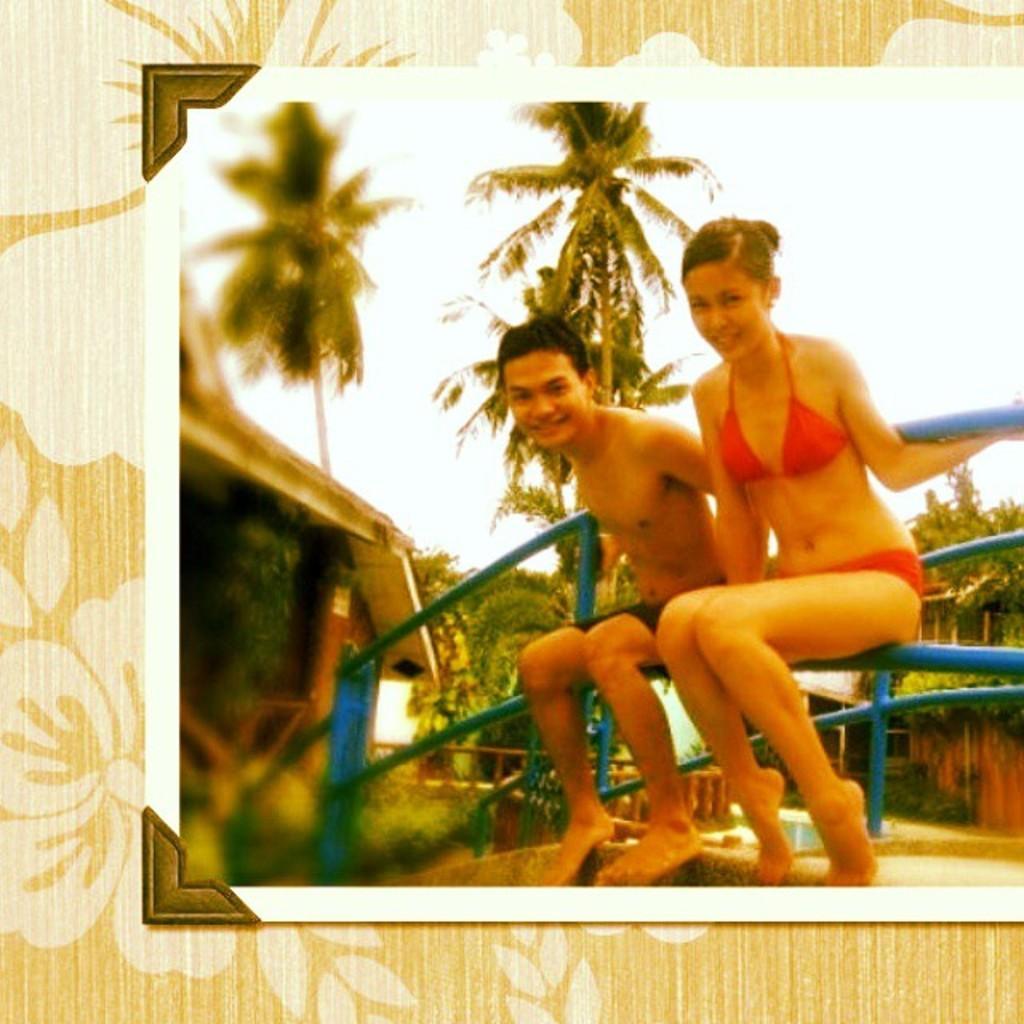Can you describe this image briefly? There is a man and a woman sitting on a railing. In the back there are many trees. And it is a photo frame. On the side there is a building and is looking blurred. 